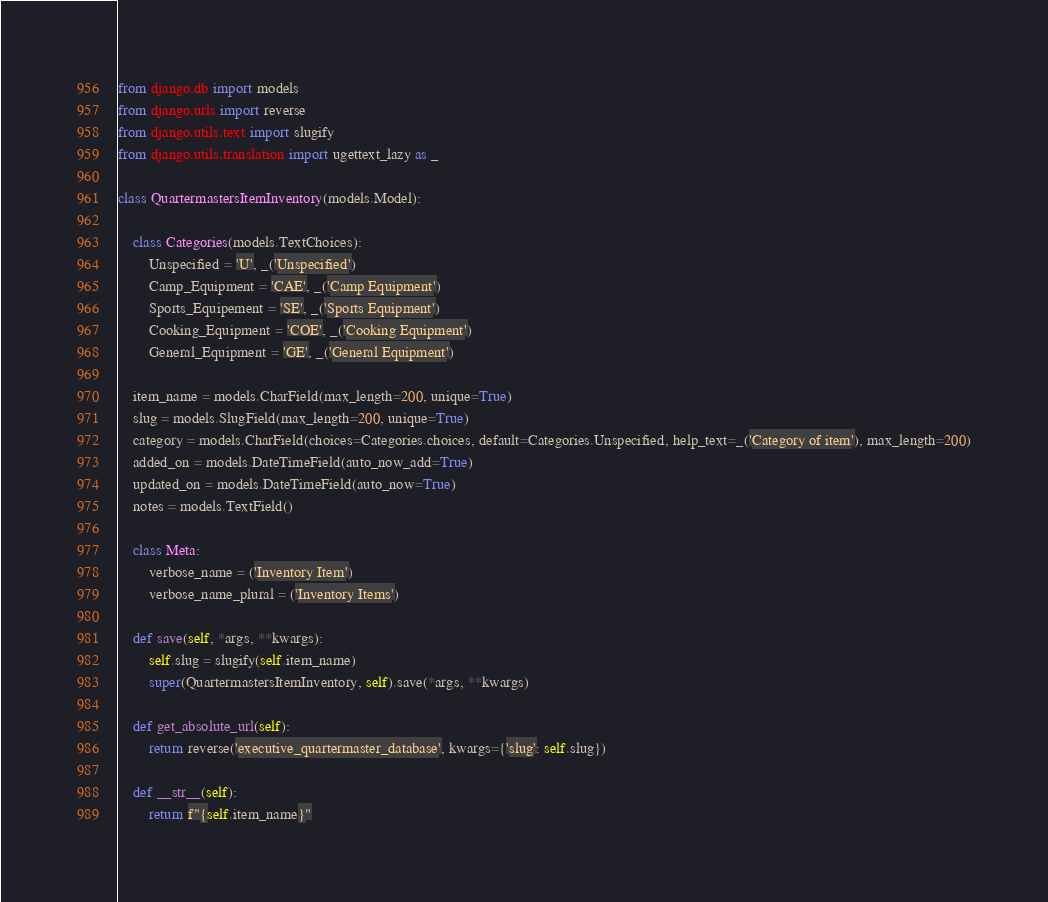<code> <loc_0><loc_0><loc_500><loc_500><_Python_>from django.db import models
from django.urls import reverse
from django.utils.text import slugify
from django.utils.translation import ugettext_lazy as _

class QuartermastersItemInventory(models.Model):

    class Categories(models.TextChoices):
        Unspecified = 'U', _('Unspecified')
        Camp_Equipment = 'CAE', _('Camp Equipment')
        Sports_Equipement = 'SE', _('Sports Equipment')
        Cooking_Equipment = 'COE', _('Cooking Equipment')
        General_Equipment = 'GE', _('General Equipment')

    item_name = models.CharField(max_length=200, unique=True)
    slug = models.SlugField(max_length=200, unique=True)
    category = models.CharField(choices=Categories.choices, default=Categories.Unspecified, help_text=_('Category of item'), max_length=200)
    added_on = models.DateTimeField(auto_now_add=True)
    updated_on = models.DateTimeField(auto_now=True)
    notes = models.TextField()

    class Meta:
	    verbose_name = ('Inventory Item')
	    verbose_name_plural = ('Inventory Items')

    def save(self, *args, **kwargs):
        self.slug = slugify(self.item_name)
        super(QuartermastersItemInventory, self).save(*args, **kwargs)

    def get_absolute_url(self):
        return reverse('executive_quartermaster_database', kwargs={'slug': self.slug})

    def __str__(self):
        return f"{self.item_name}"</code> 